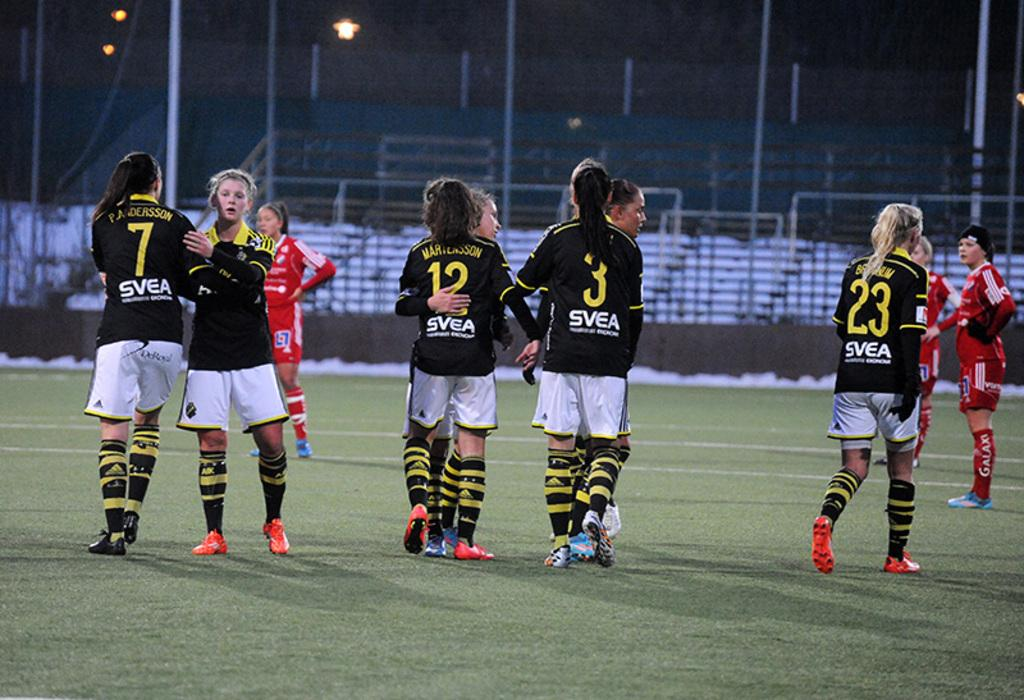Provide a one-sentence caption for the provided image. A group of soccor players with number 23 walking to the right. 